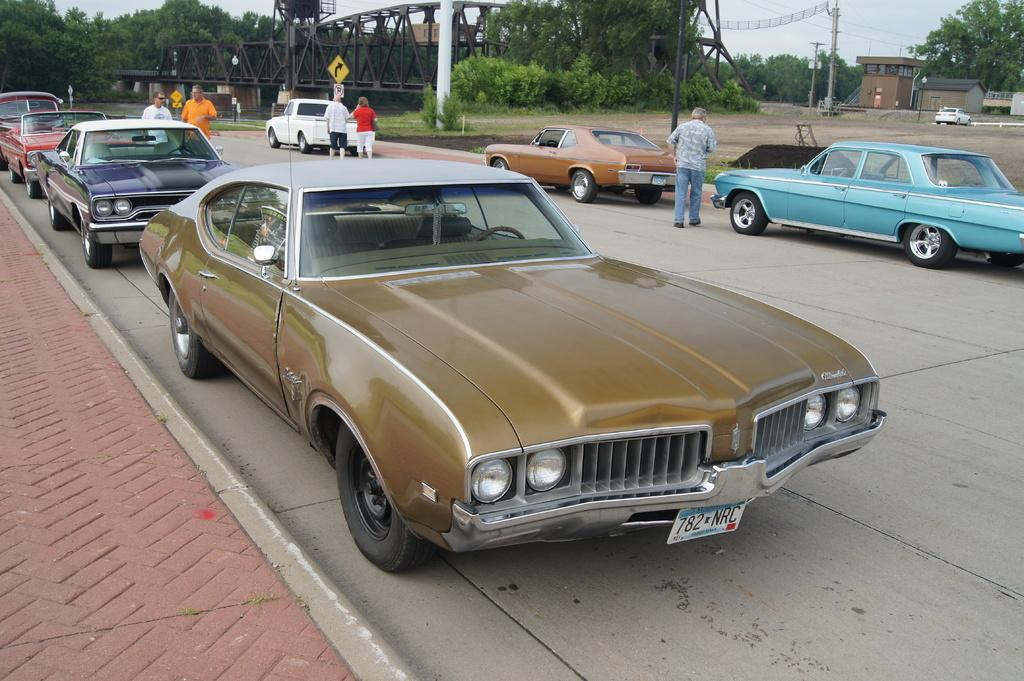What type of vehicles can be seen in the image? There are cars in the image. Who or what else is present in the image? There are people in the image. Where are the cars and people located? The cars and people are on the road in the image. What other objects can be seen in the image? There are sign boards, poles, trees, and buildings in the image. Can you see a tiger walking down the alley in the image? There is no alley or tiger present in the image. What type of fruit is hanging from the trees in the image? There is no fruit mentioned or visible in the image; only trees are present. 